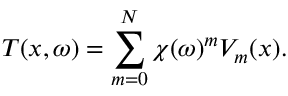<formula> <loc_0><loc_0><loc_500><loc_500>T ( x , \omega ) = \sum _ { m = 0 } ^ { N } \chi ( \omega ) ^ { m } V _ { m } ( x ) .</formula> 